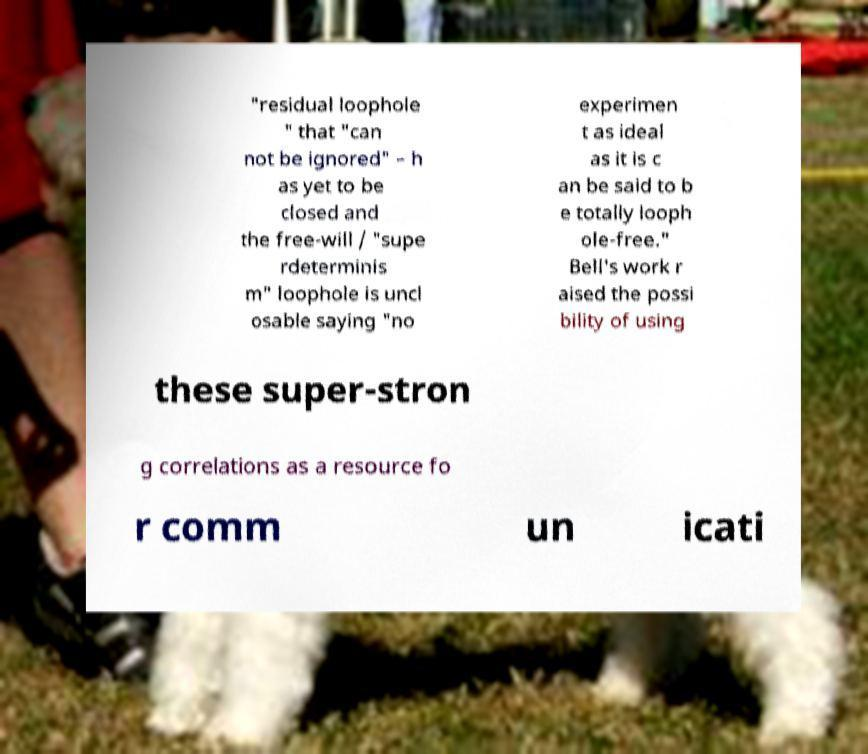Could you assist in decoding the text presented in this image and type it out clearly? "residual loophole " that "can not be ignored" – h as yet to be closed and the free-will / "supe rdeterminis m" loophole is uncl osable saying "no experimen t as ideal as it is c an be said to b e totally looph ole-free." Bell's work r aised the possi bility of using these super-stron g correlations as a resource fo r comm un icati 